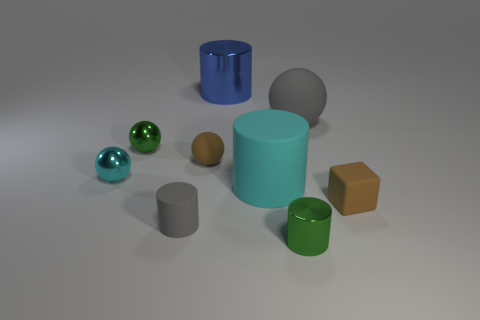What number of things have the same size as the brown matte block?
Ensure brevity in your answer.  5. How many rubber things are either tiny brown objects or cyan objects?
Provide a succinct answer. 3. What size is the rubber thing that is the same color as the large rubber sphere?
Offer a very short reply. Small. What material is the gray object that is to the left of the matte cylinder that is behind the tiny matte block?
Offer a terse response. Rubber. How many things are large red matte cubes or small metallic objects to the right of the cyan ball?
Make the answer very short. 2. There is a cyan thing that is made of the same material as the blue object; what is its size?
Provide a short and direct response. Small. What number of brown things are big things or small matte objects?
Make the answer very short. 2. The tiny thing that is the same color as the big sphere is what shape?
Offer a terse response. Cylinder. Is there anything else that is the same material as the large cyan object?
Keep it short and to the point. Yes. There is a thing behind the big gray rubber thing; does it have the same shape as the green object that is left of the green metallic cylinder?
Your answer should be compact. No. 